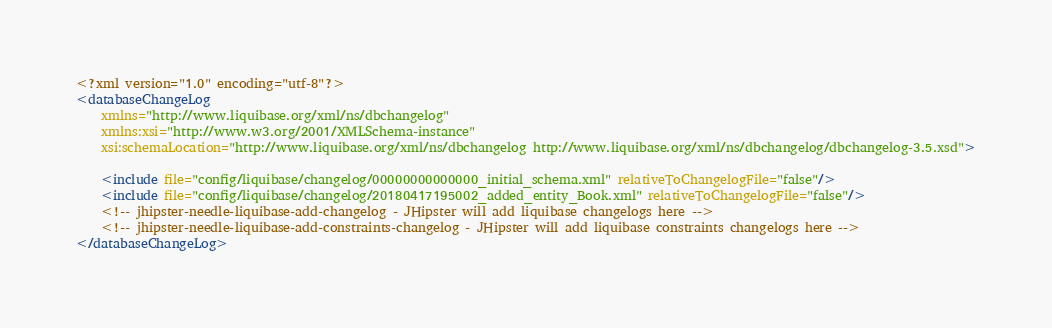<code> <loc_0><loc_0><loc_500><loc_500><_XML_><?xml version="1.0" encoding="utf-8"?>
<databaseChangeLog
    xmlns="http://www.liquibase.org/xml/ns/dbchangelog"
    xmlns:xsi="http://www.w3.org/2001/XMLSchema-instance"
    xsi:schemaLocation="http://www.liquibase.org/xml/ns/dbchangelog http://www.liquibase.org/xml/ns/dbchangelog/dbchangelog-3.5.xsd">

    <include file="config/liquibase/changelog/00000000000000_initial_schema.xml" relativeToChangelogFile="false"/>
    <include file="config/liquibase/changelog/20180417195002_added_entity_Book.xml" relativeToChangelogFile="false"/>
    <!-- jhipster-needle-liquibase-add-changelog - JHipster will add liquibase changelogs here -->
    <!-- jhipster-needle-liquibase-add-constraints-changelog - JHipster will add liquibase constraints changelogs here -->
</databaseChangeLog>
</code> 